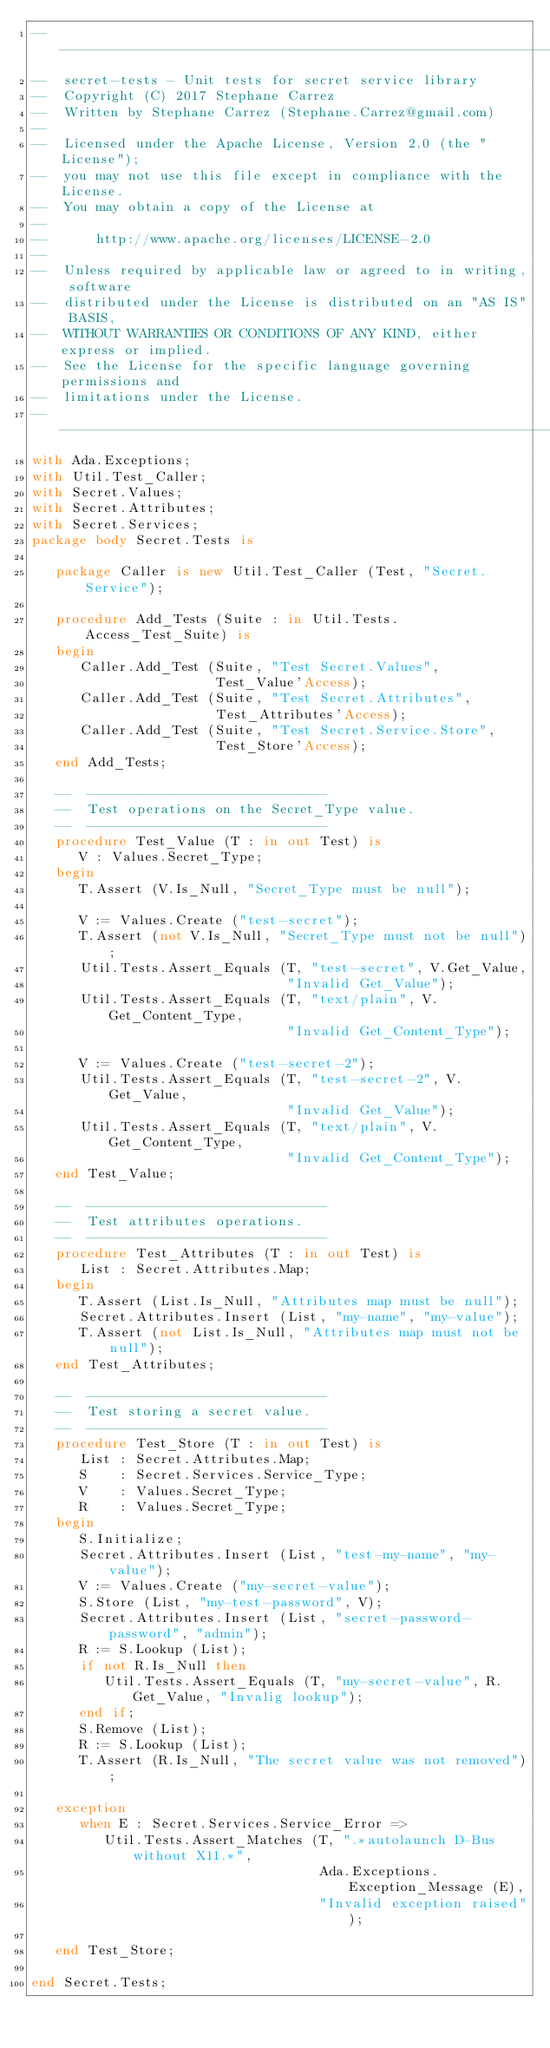<code> <loc_0><loc_0><loc_500><loc_500><_Ada_>-----------------------------------------------------------------------
--  secret-tests - Unit tests for secret service library
--  Copyright (C) 2017 Stephane Carrez
--  Written by Stephane Carrez (Stephane.Carrez@gmail.com)
--
--  Licensed under the Apache License, Version 2.0 (the "License");
--  you may not use this file except in compliance with the License.
--  You may obtain a copy of the License at
--
--      http://www.apache.org/licenses/LICENSE-2.0
--
--  Unless required by applicable law or agreed to in writing, software
--  distributed under the License is distributed on an "AS IS" BASIS,
--  WITHOUT WARRANTIES OR CONDITIONS OF ANY KIND, either express or implied.
--  See the License for the specific language governing permissions and
--  limitations under the License.
-----------------------------------------------------------------------
with Ada.Exceptions;
with Util.Test_Caller;
with Secret.Values;
with Secret.Attributes;
with Secret.Services;
package body Secret.Tests is

   package Caller is new Util.Test_Caller (Test, "Secret.Service");

   procedure Add_Tests (Suite : in Util.Tests.Access_Test_Suite) is
   begin
      Caller.Add_Test (Suite, "Test Secret.Values",
                       Test_Value'Access);
      Caller.Add_Test (Suite, "Test Secret.Attributes",
                       Test_Attributes'Access);
      Caller.Add_Test (Suite, "Test Secret.Service.Store",
                       Test_Store'Access);
   end Add_Tests;

   --  ------------------------------
   --  Test operations on the Secret_Type value.
   --  ------------------------------
   procedure Test_Value (T : in out Test) is
      V : Values.Secret_Type;
   begin
      T.Assert (V.Is_Null, "Secret_Type must be null");

      V := Values.Create ("test-secret");
      T.Assert (not V.Is_Null, "Secret_Type must not be null");
      Util.Tests.Assert_Equals (T, "test-secret", V.Get_Value,
                                "Invalid Get_Value");
      Util.Tests.Assert_Equals (T, "text/plain", V.Get_Content_Type,
                                "Invalid Get_Content_Type");

      V := Values.Create ("test-secret-2");
      Util.Tests.Assert_Equals (T, "test-secret-2", V.Get_Value,
                                "Invalid Get_Value");
      Util.Tests.Assert_Equals (T, "text/plain", V.Get_Content_Type,
                                "Invalid Get_Content_Type");
   end Test_Value;

   --  ------------------------------
   --  Test attributes operations.
   --  ------------------------------
   procedure Test_Attributes (T : in out Test) is
      List : Secret.Attributes.Map;
   begin
      T.Assert (List.Is_Null, "Attributes map must be null");
      Secret.Attributes.Insert (List, "my-name", "my-value");
      T.Assert (not List.Is_Null, "Attributes map must not be null");
   end Test_Attributes;

   --  ------------------------------
   --  Test storing a secret value.
   --  ------------------------------
   procedure Test_Store (T : in out Test) is
      List : Secret.Attributes.Map;
      S    : Secret.Services.Service_Type;
      V    : Values.Secret_Type;
      R    : Values.Secret_Type;
   begin
      S.Initialize;
      Secret.Attributes.Insert (List, "test-my-name", "my-value");
      V := Values.Create ("my-secret-value");
      S.Store (List, "my-test-password", V);
      Secret.Attributes.Insert (List, "secret-password-password", "admin");
      R := S.Lookup (List);
      if not R.Is_Null then
         Util.Tests.Assert_Equals (T, "my-secret-value", R.Get_Value, "Invalig lookup");
      end if;
      S.Remove (List);
      R := S.Lookup (List);
      T.Assert (R.Is_Null, "The secret value was not removed");

   exception
      when E : Secret.Services.Service_Error =>
         Util.Tests.Assert_Matches (T, ".*autolaunch D-Bus without X11.*",
                                    Ada.Exceptions.Exception_Message (E),
                                    "Invalid exception raised");

   end Test_Store;

end Secret.Tests;
</code> 